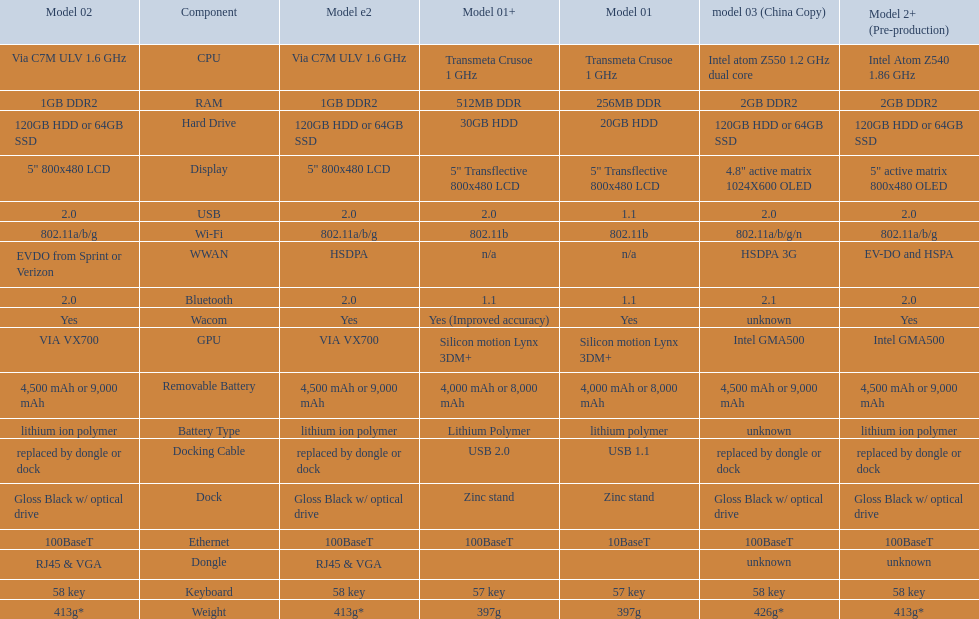What is the average number of models that have usb 2.0? 5. 